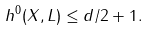Convert formula to latex. <formula><loc_0><loc_0><loc_500><loc_500>h ^ { 0 } ( X , L ) \leq d / 2 + 1 .</formula> 